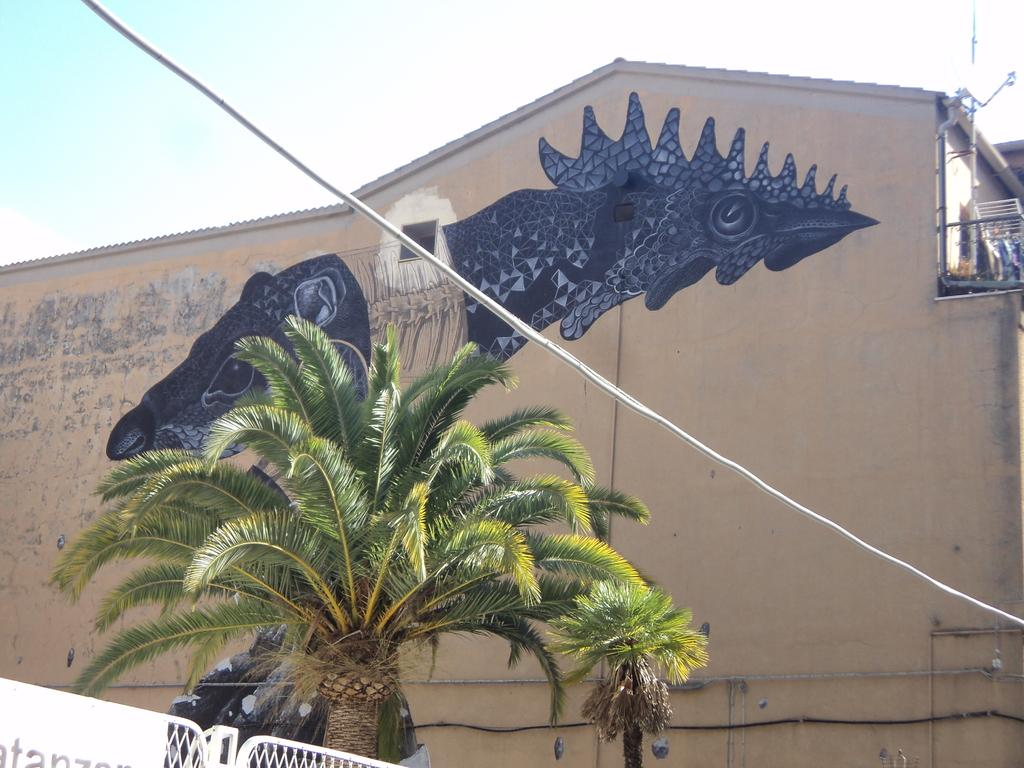What is depicted on the wall in the image? There is an image of an animal on the wall. What type of structure can be seen in the image? There is a building in the image. What natural element is present in the image? There is a tree in the image. What architectural feature is visible in the image? There is a fence in the image. What man-made object can be seen in the image? There is a white cable in the image. What is the condition of the sky in the image? The sky is clear in the image. How many eggs are visible in the image? There are no eggs present in the image. What is the name of the daughter in the image? There is no daughter present in the image. 